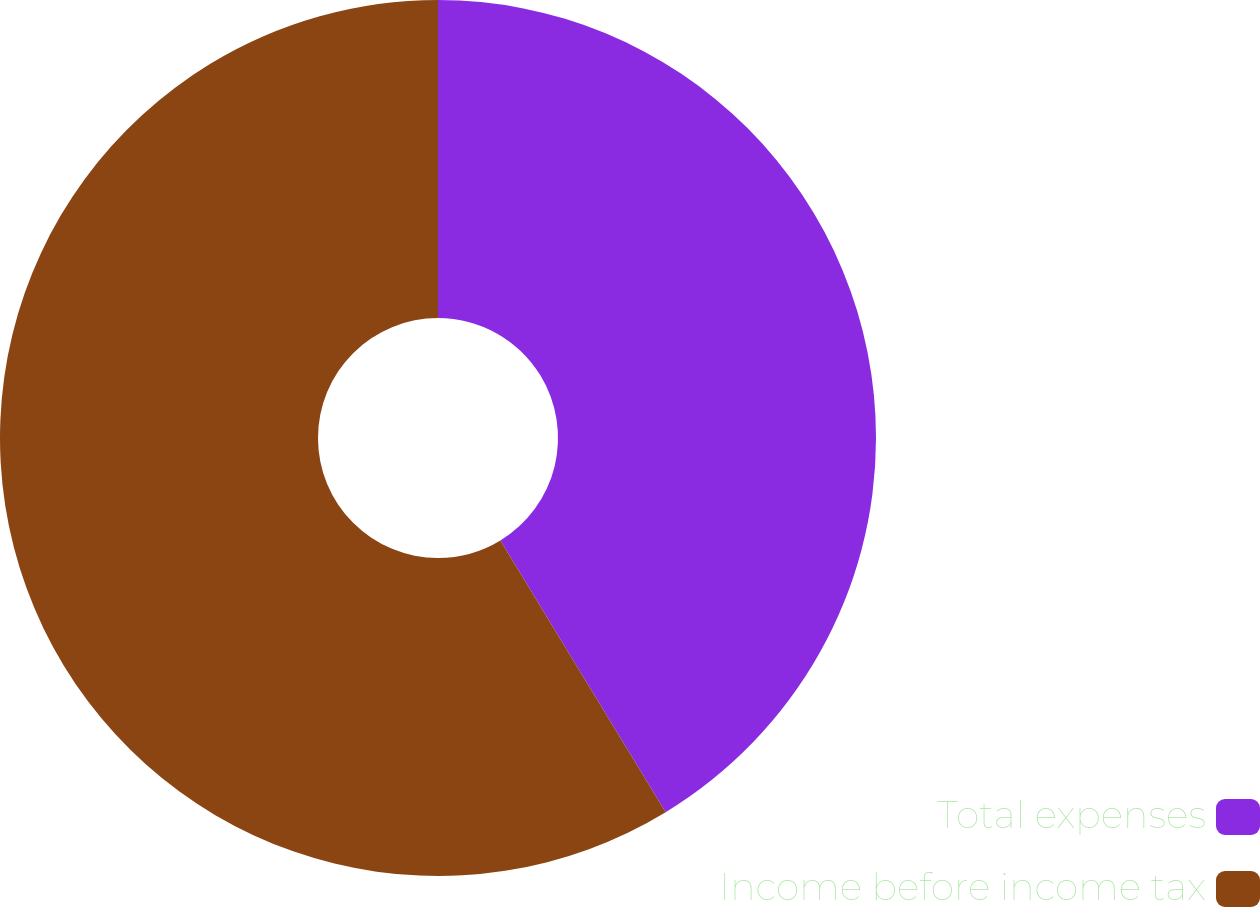Convert chart. <chart><loc_0><loc_0><loc_500><loc_500><pie_chart><fcel>Total expenses<fcel>Income before income tax<nl><fcel>41.3%<fcel>58.7%<nl></chart> 